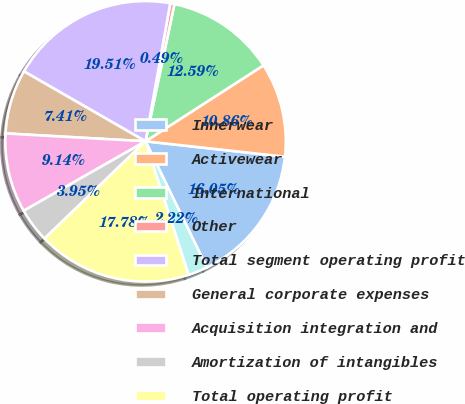<chart> <loc_0><loc_0><loc_500><loc_500><pie_chart><fcel>Innerwear<fcel>Activewear<fcel>International<fcel>Other<fcel>Total segment operating profit<fcel>General corporate expenses<fcel>Acquisition integration and<fcel>Amortization of intangibles<fcel>Total operating profit<fcel>Other expenses<nl><fcel>16.05%<fcel>10.86%<fcel>12.59%<fcel>0.49%<fcel>19.51%<fcel>7.41%<fcel>9.14%<fcel>3.95%<fcel>17.78%<fcel>2.22%<nl></chart> 